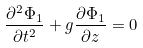Convert formula to latex. <formula><loc_0><loc_0><loc_500><loc_500>\frac { \partial ^ { 2 } \Phi _ { 1 } } { \partial t ^ { 2 } } + g \frac { \partial \Phi _ { 1 } } { \partial z } = 0</formula> 